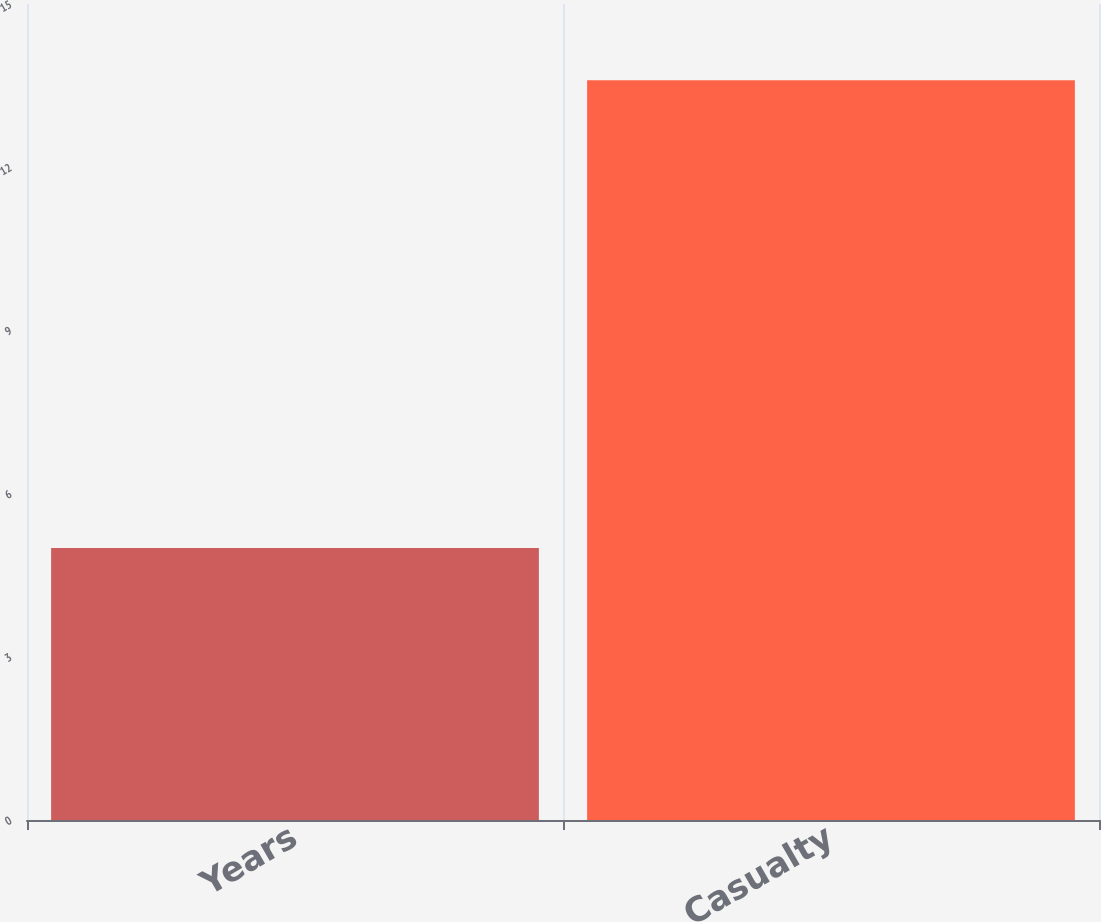Convert chart to OTSL. <chart><loc_0><loc_0><loc_500><loc_500><bar_chart><fcel>Years<fcel>Casualty<nl><fcel>5<fcel>13.6<nl></chart> 